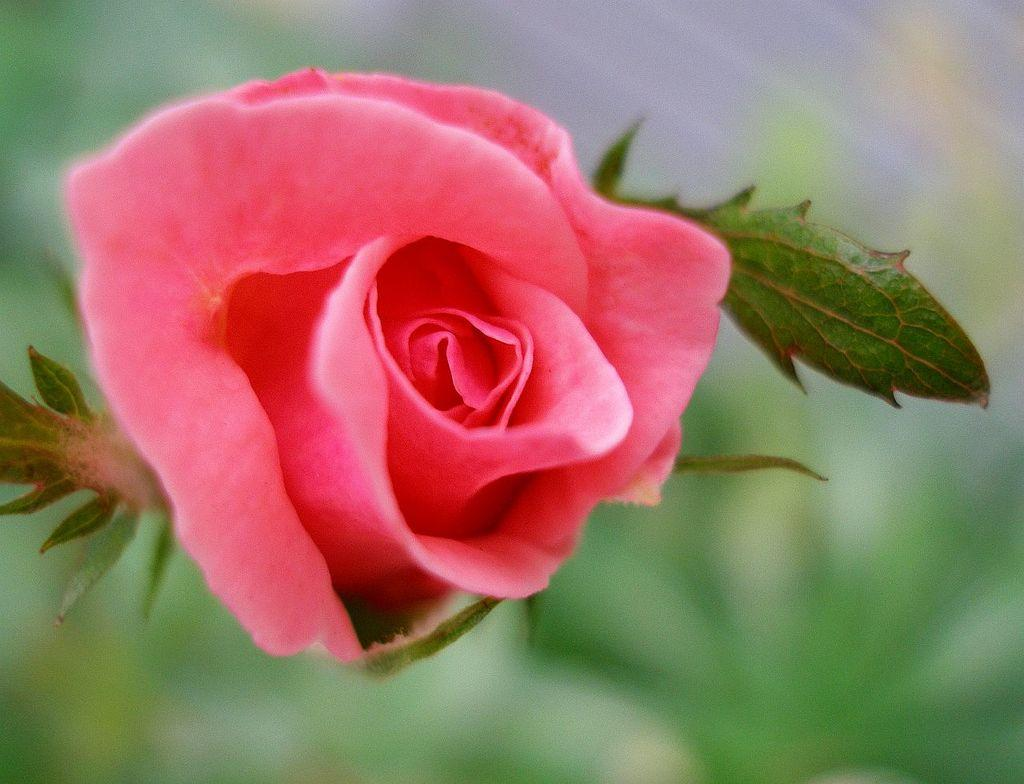What type of flower is in the image? There is a pink color rose in the image. What else can be seen near the rose in the image? There are leaves beside the rose in the image. How is the rose being used in the image? The image does not show the rose being used for any specific purpose. 